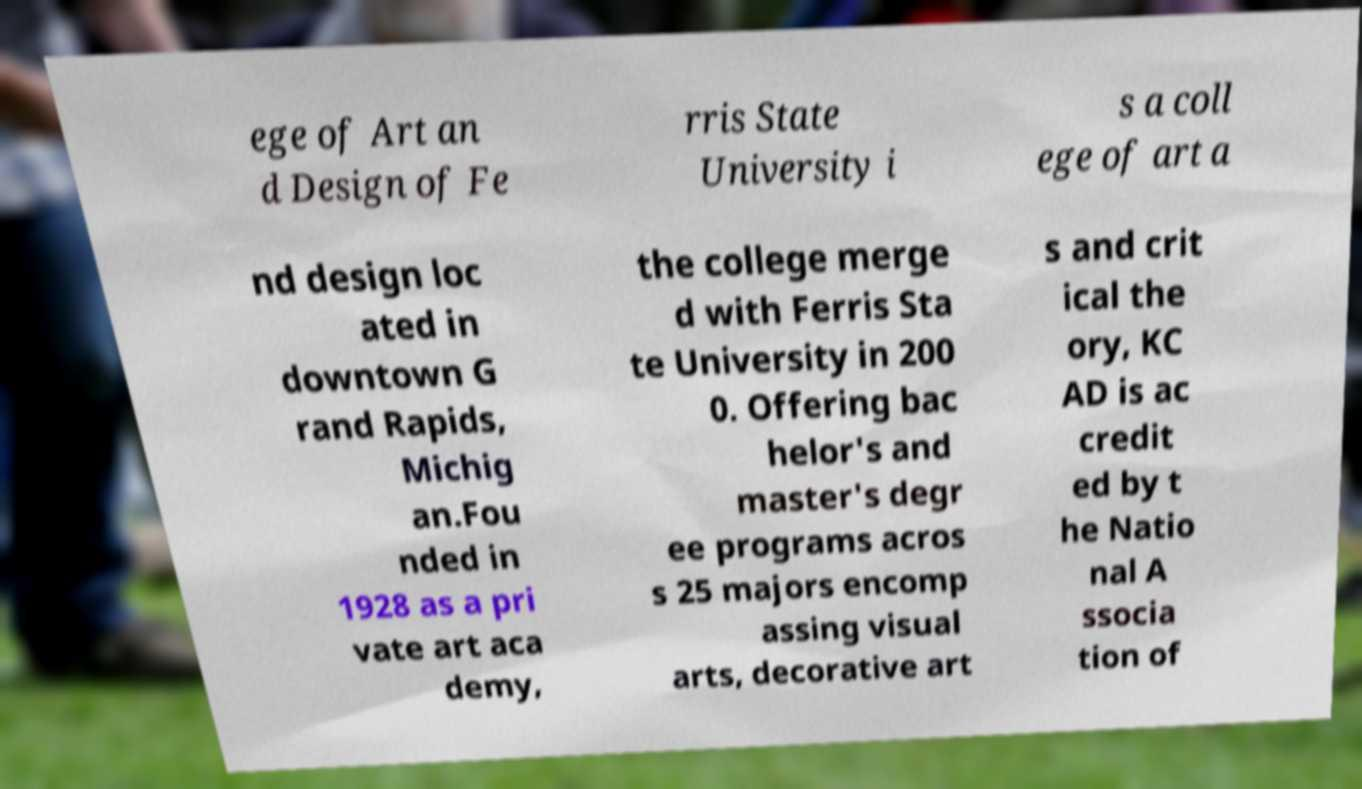Please read and relay the text visible in this image. What does it say? ege of Art an d Design of Fe rris State University i s a coll ege of art a nd design loc ated in downtown G rand Rapids, Michig an.Fou nded in 1928 as a pri vate art aca demy, the college merge d with Ferris Sta te University in 200 0. Offering bac helor's and master's degr ee programs acros s 25 majors encomp assing visual arts, decorative art s and crit ical the ory, KC AD is ac credit ed by t he Natio nal A ssocia tion of 